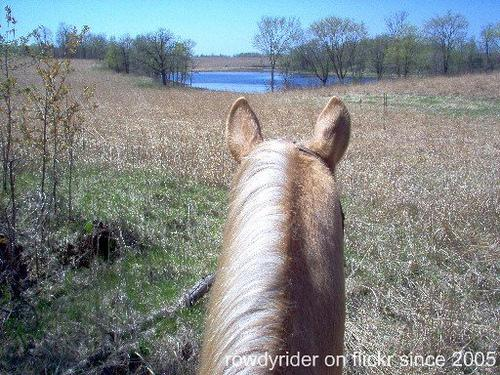Question: where is the horse at?
Choices:
A. Barn.
B. Grassy field.
C. By the pond.
D. Running by the fence.
Answer with the letter. Answer: B Question: what is in the distance?
Choices:
A. Mountain.
B. Bridge.
C. Lake.
D. Tall building.
Answer with the letter. Answer: C Question: what is surrounding the lake?
Choices:
A. Campers.
B. Trees.
C. Fence.
D. Rocks.
Answer with the letter. Answer: B Question: who is with the horse?
Choices:
A. The jockey.
B. Horse trainer.
C. No one.
D. The man.
Answer with the letter. Answer: C 